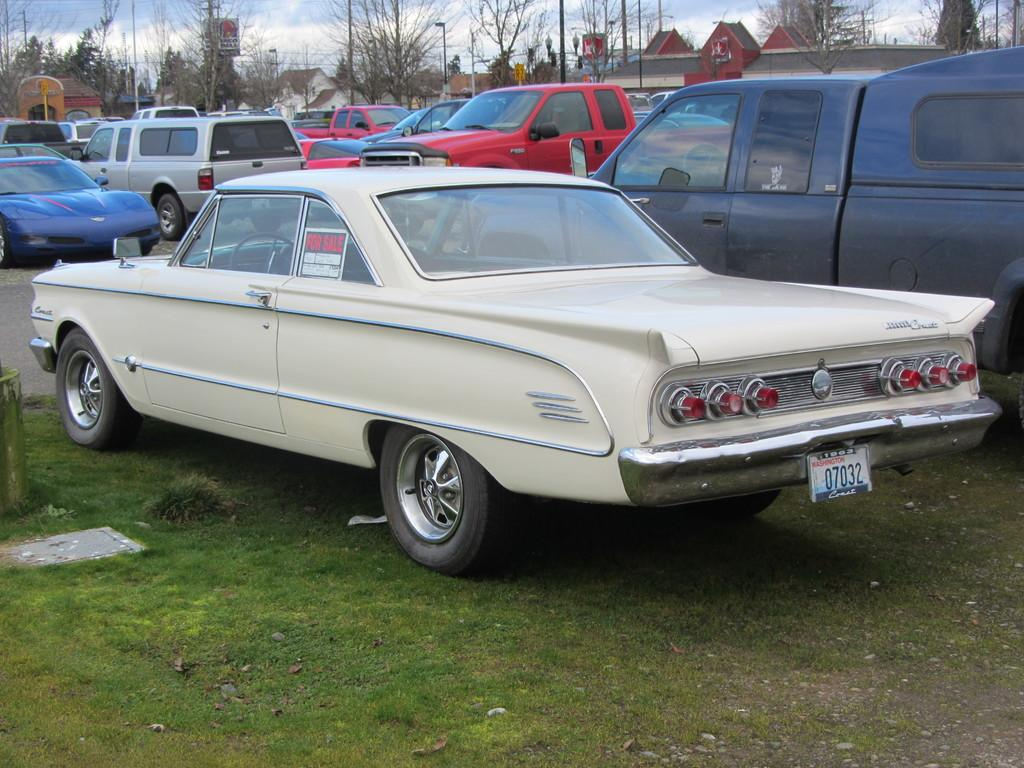What can be seen on the road in the image? There are many cars parked on the road. What is visible in the background of the image? There are buildings, trees, and the sky visible in the background of the image. Where is the coat hanging in the image? There is no coat present in the image. What type of paper can be seen on the floor in the image? There is no paper visible on the floor in the image. 